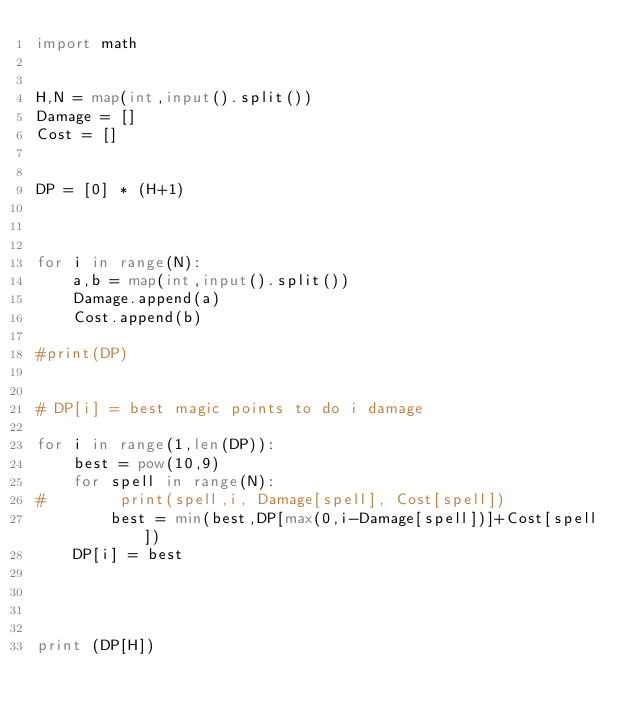<code> <loc_0><loc_0><loc_500><loc_500><_Python_>import math


H,N = map(int,input().split())
Damage = []
Cost = []


DP = [0] * (H+1)



for i in range(N):
    a,b = map(int,input().split())
    Damage.append(a)
    Cost.append(b)
    
#print(DP)


# DP[i] = best magic points to do i damage

for i in range(1,len(DP)):
    best = pow(10,9)
    for spell in range(N):
#        print(spell,i, Damage[spell], Cost[spell])
        best = min(best,DP[max(0,i-Damage[spell])]+Cost[spell])
    DP[i] = best




print (DP[H])

</code> 